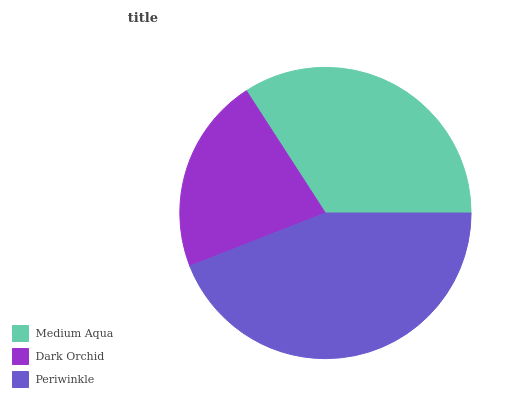Is Dark Orchid the minimum?
Answer yes or no. Yes. Is Periwinkle the maximum?
Answer yes or no. Yes. Is Periwinkle the minimum?
Answer yes or no. No. Is Dark Orchid the maximum?
Answer yes or no. No. Is Periwinkle greater than Dark Orchid?
Answer yes or no. Yes. Is Dark Orchid less than Periwinkle?
Answer yes or no. Yes. Is Dark Orchid greater than Periwinkle?
Answer yes or no. No. Is Periwinkle less than Dark Orchid?
Answer yes or no. No. Is Medium Aqua the high median?
Answer yes or no. Yes. Is Medium Aqua the low median?
Answer yes or no. Yes. Is Dark Orchid the high median?
Answer yes or no. No. Is Dark Orchid the low median?
Answer yes or no. No. 